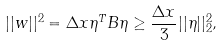Convert formula to latex. <formula><loc_0><loc_0><loc_500><loc_500>| | w | | ^ { 2 } = \Delta x \eta ^ { T } B \eta \geq \frac { \Delta x } { 3 } | | \eta | | ^ { 2 } _ { 2 } ,</formula> 